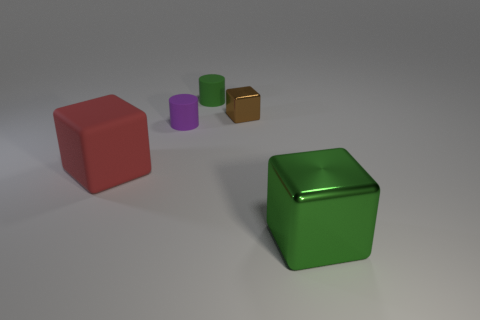What number of rubber objects are small purple things or small brown blocks?
Provide a succinct answer. 1. There is a metal object that is behind the block in front of the large red object; what is its shape?
Make the answer very short. Cube. Are there fewer small purple matte cylinders that are to the right of the green matte thing than small purple matte things?
Offer a terse response. Yes. What shape is the large matte thing?
Your answer should be compact. Cube. What is the size of the metallic cube that is behind the rubber cube?
Keep it short and to the point. Small. There is a thing that is the same size as the matte block; what is its color?
Keep it short and to the point. Green. Are there any large shiny spheres of the same color as the large metallic block?
Make the answer very short. No. Is the number of small cylinders behind the tiny brown object less than the number of small metallic things behind the small green cylinder?
Keep it short and to the point. No. There is a small thing that is on the left side of the tiny brown metal block and right of the purple object; what is it made of?
Your response must be concise. Rubber. Is the shape of the purple matte object the same as the large thing behind the big green metal object?
Provide a short and direct response. No. 